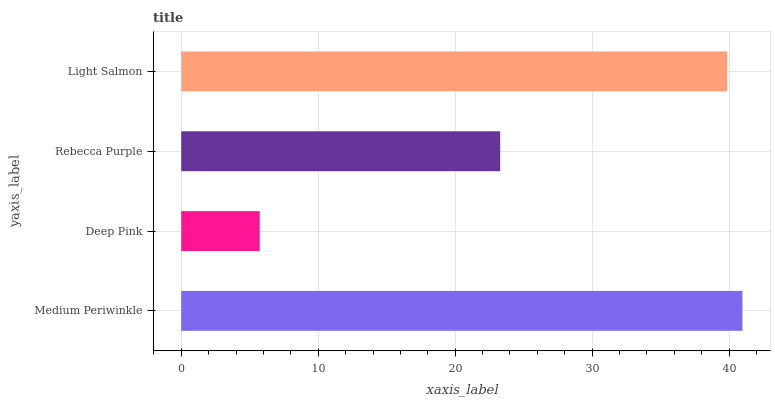Is Deep Pink the minimum?
Answer yes or no. Yes. Is Medium Periwinkle the maximum?
Answer yes or no. Yes. Is Rebecca Purple the minimum?
Answer yes or no. No. Is Rebecca Purple the maximum?
Answer yes or no. No. Is Rebecca Purple greater than Deep Pink?
Answer yes or no. Yes. Is Deep Pink less than Rebecca Purple?
Answer yes or no. Yes. Is Deep Pink greater than Rebecca Purple?
Answer yes or no. No. Is Rebecca Purple less than Deep Pink?
Answer yes or no. No. Is Light Salmon the high median?
Answer yes or no. Yes. Is Rebecca Purple the low median?
Answer yes or no. Yes. Is Rebecca Purple the high median?
Answer yes or no. No. Is Medium Periwinkle the low median?
Answer yes or no. No. 